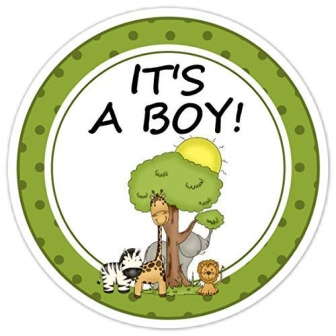What is this photo about? The image showcases a vibrant, circular sticker with a green border and a white center. At the heart of this sticker lies a whimsical illustration featuring a giraffe, a lion, and a zebra standing cheerfully under a large tree. A yellow bird adds a splash of color as it perches on a branch, while the sun shines behind the tree, evoking a delightful outdoor setting. Above this charming scene, the message 'IT'S A BOY!' is playfully written, indicating the sticker is designed to celebrate the arrival of a newborn baby boy. 